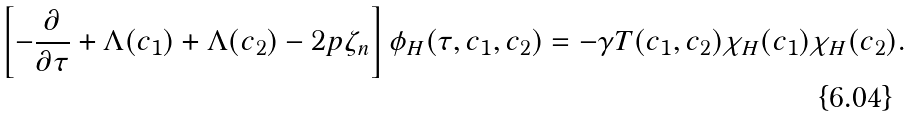<formula> <loc_0><loc_0><loc_500><loc_500>\left [ - \frac { \partial } { \partial \tau } + \Lambda ( c _ { 1 } ) + \Lambda ( c _ { 2 } ) - 2 p \zeta _ { n } \right ] \phi _ { H } ( \tau , c _ { 1 } , c _ { 2 } ) = - \gamma T ( c _ { 1 } , c _ { 2 } ) \chi _ { H } ( c _ { 1 } ) \chi _ { H } ( c _ { 2 } ) .</formula> 